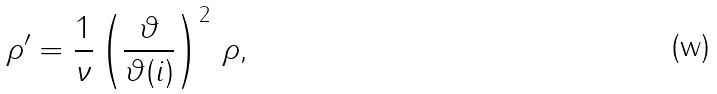<formula> <loc_0><loc_0><loc_500><loc_500>\rho ^ { \prime } = \frac { 1 } { \nu } \left ( \frac { \vartheta } { \vartheta ( i ) } \right ) ^ { 2 } \, \rho ,</formula> 